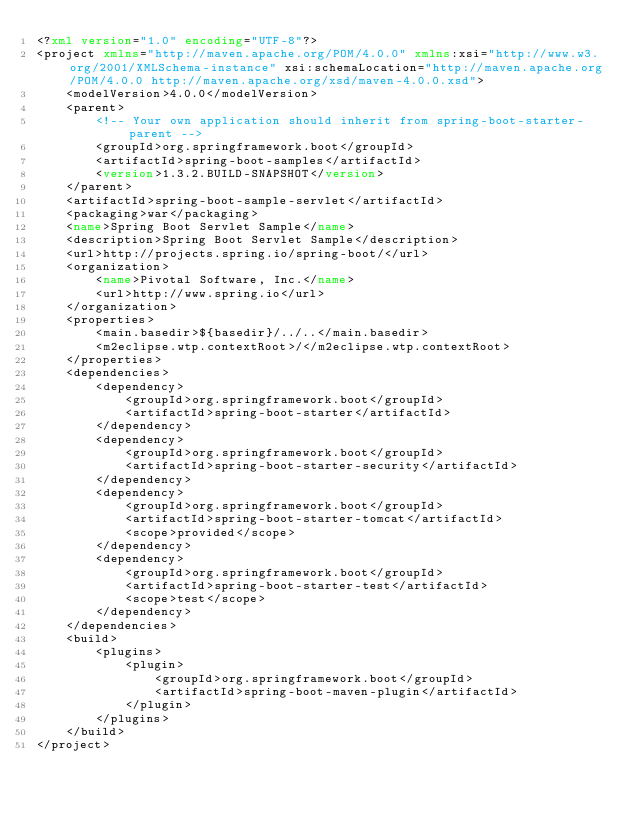<code> <loc_0><loc_0><loc_500><loc_500><_XML_><?xml version="1.0" encoding="UTF-8"?>
<project xmlns="http://maven.apache.org/POM/4.0.0" xmlns:xsi="http://www.w3.org/2001/XMLSchema-instance" xsi:schemaLocation="http://maven.apache.org/POM/4.0.0 http://maven.apache.org/xsd/maven-4.0.0.xsd">
	<modelVersion>4.0.0</modelVersion>
	<parent>
		<!-- Your own application should inherit from spring-boot-starter-parent -->
		<groupId>org.springframework.boot</groupId>
		<artifactId>spring-boot-samples</artifactId>
		<version>1.3.2.BUILD-SNAPSHOT</version>
	</parent>
	<artifactId>spring-boot-sample-servlet</artifactId>
	<packaging>war</packaging>
	<name>Spring Boot Servlet Sample</name>
	<description>Spring Boot Servlet Sample</description>
	<url>http://projects.spring.io/spring-boot/</url>
	<organization>
		<name>Pivotal Software, Inc.</name>
		<url>http://www.spring.io</url>
	</organization>
	<properties>
		<main.basedir>${basedir}/../..</main.basedir>
		<m2eclipse.wtp.contextRoot>/</m2eclipse.wtp.contextRoot>
	</properties>
	<dependencies>
		<dependency>
			<groupId>org.springframework.boot</groupId>
			<artifactId>spring-boot-starter</artifactId>
		</dependency>
		<dependency>
			<groupId>org.springframework.boot</groupId>
			<artifactId>spring-boot-starter-security</artifactId>
		</dependency>
		<dependency>
			<groupId>org.springframework.boot</groupId>
			<artifactId>spring-boot-starter-tomcat</artifactId>
			<scope>provided</scope>
		</dependency>
		<dependency>
			<groupId>org.springframework.boot</groupId>
			<artifactId>spring-boot-starter-test</artifactId>
			<scope>test</scope>
		</dependency>
	</dependencies>
	<build>
		<plugins>
			<plugin>
				<groupId>org.springframework.boot</groupId>
				<artifactId>spring-boot-maven-plugin</artifactId>
			</plugin>
		</plugins>
	</build>
</project>
</code> 